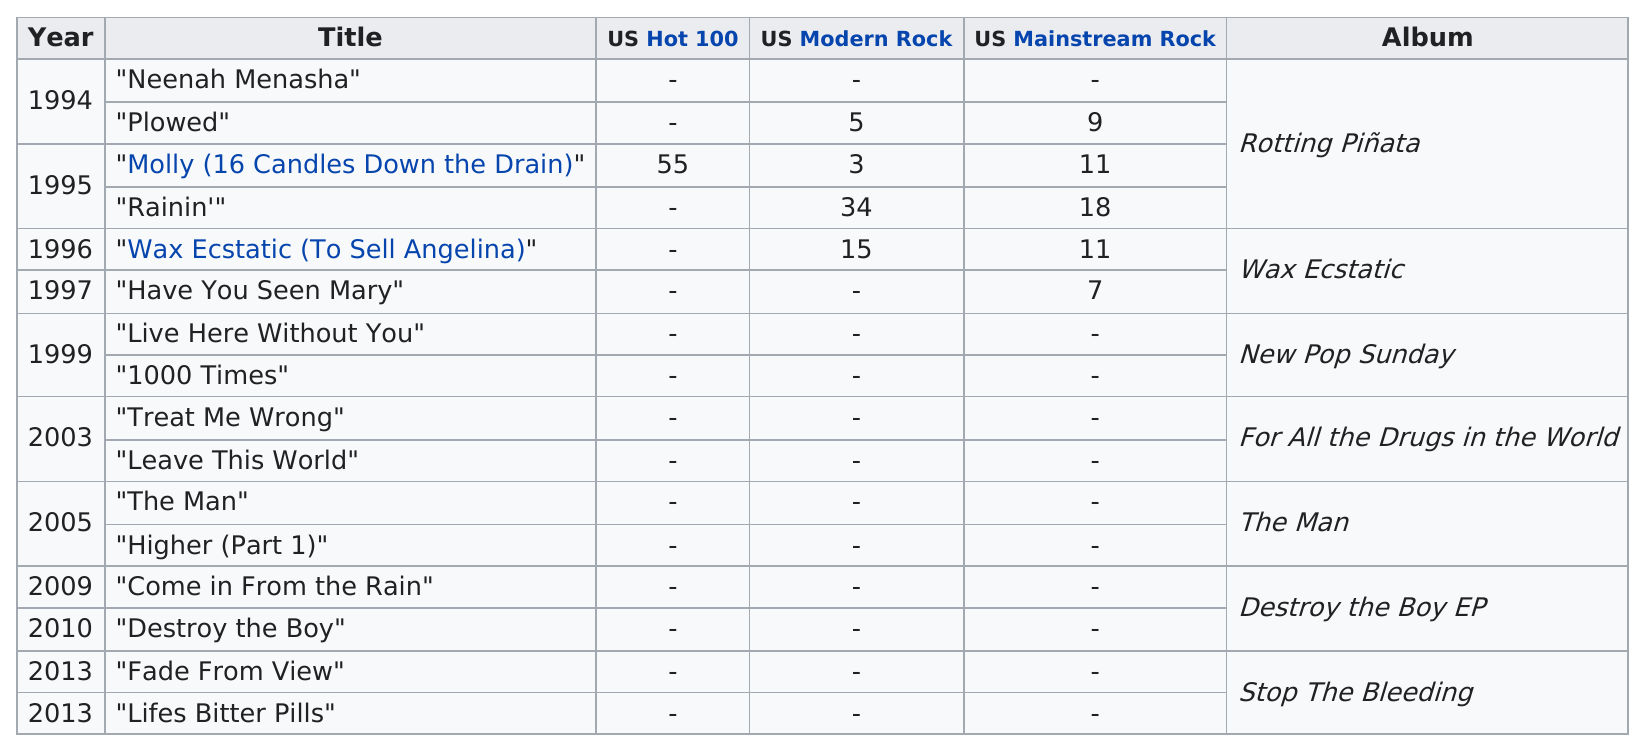Draw attention to some important aspects in this diagram. Before 1000 times, in the year 1999, the song "Live Here Without You" was listed. As of 2021, the total number of singles released since 1994 is 16. The album "Rotting Piñata" had the most singles releases out of all of its counterparts. Come in From the Rain" is the only single from 2009. The first single listed is 'Neenah Menasha'. 